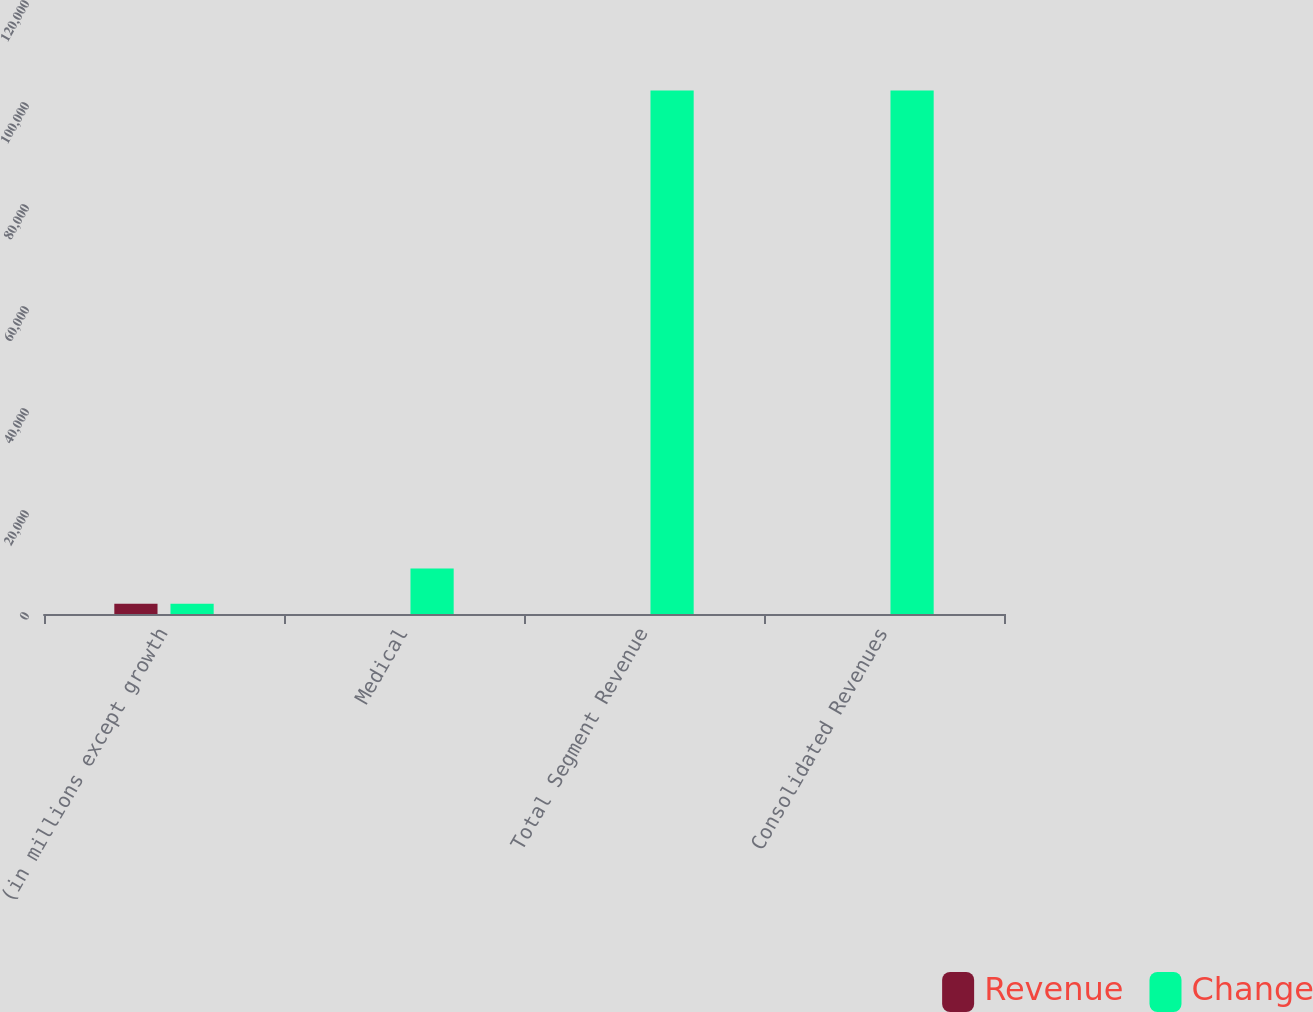Convert chart. <chart><loc_0><loc_0><loc_500><loc_500><stacked_bar_chart><ecel><fcel>(in millions except growth<fcel>Medical<fcel>Total Segment Revenue<fcel>Consolidated Revenues<nl><fcel>Revenue<fcel>2011<fcel>2<fcel>4<fcel>4<nl><fcel>Change<fcel>2011<fcel>8921.5<fcel>102665<fcel>102644<nl></chart> 